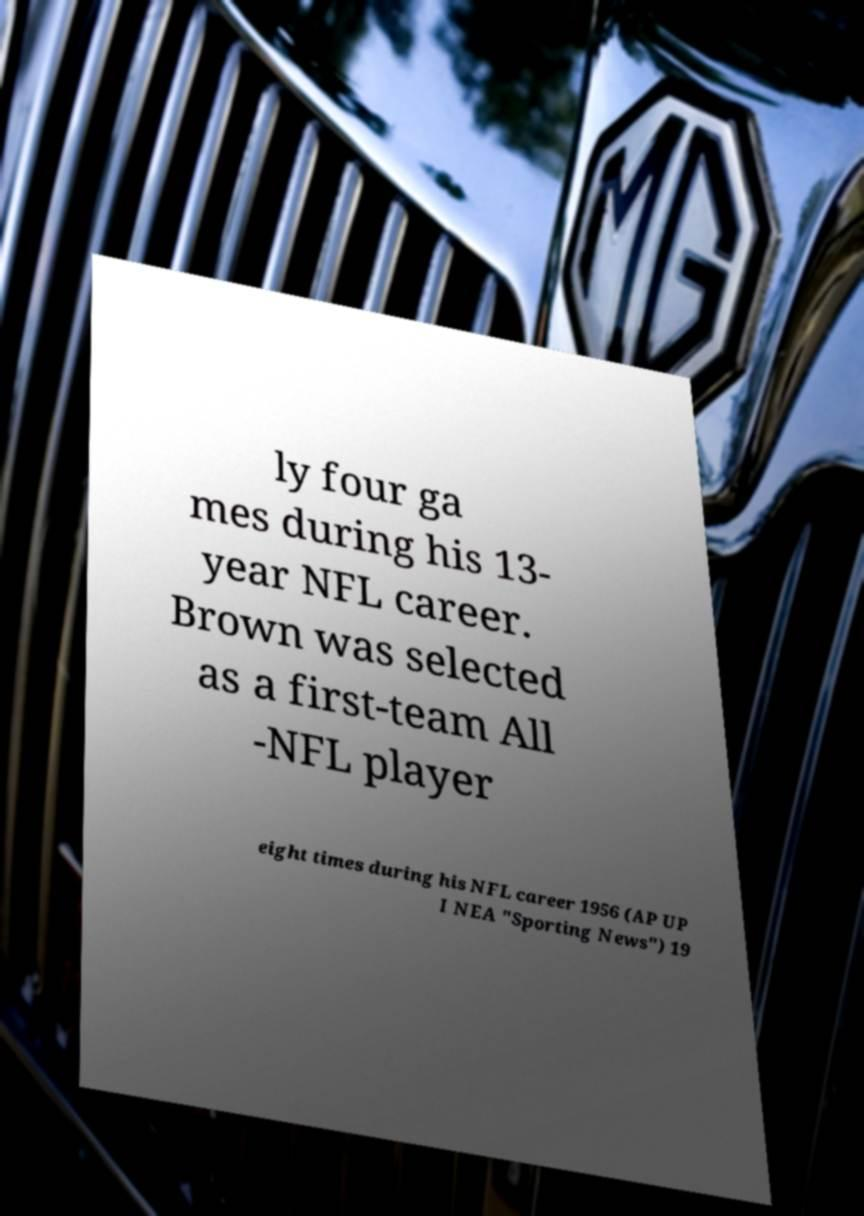For documentation purposes, I need the text within this image transcribed. Could you provide that? ly four ga mes during his 13- year NFL career. Brown was selected as a first-team All -NFL player eight times during his NFL career 1956 (AP UP I NEA "Sporting News") 19 